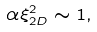<formula> <loc_0><loc_0><loc_500><loc_500>\alpha \xi _ { 2 D } ^ { 2 } \sim 1 ,</formula> 